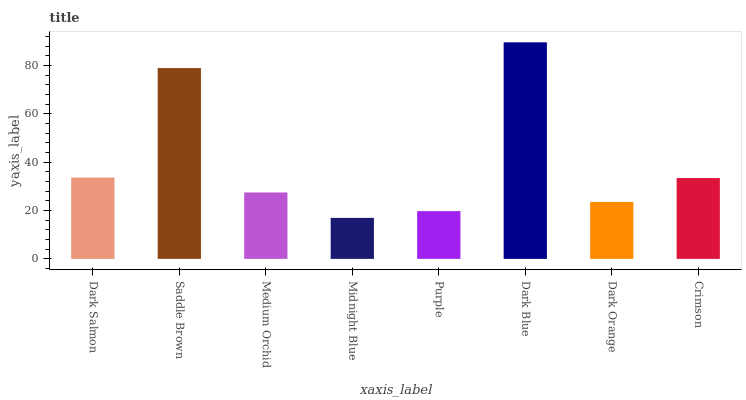Is Midnight Blue the minimum?
Answer yes or no. Yes. Is Dark Blue the maximum?
Answer yes or no. Yes. Is Saddle Brown the minimum?
Answer yes or no. No. Is Saddle Brown the maximum?
Answer yes or no. No. Is Saddle Brown greater than Dark Salmon?
Answer yes or no. Yes. Is Dark Salmon less than Saddle Brown?
Answer yes or no. Yes. Is Dark Salmon greater than Saddle Brown?
Answer yes or no. No. Is Saddle Brown less than Dark Salmon?
Answer yes or no. No. Is Crimson the high median?
Answer yes or no. Yes. Is Medium Orchid the low median?
Answer yes or no. Yes. Is Dark Salmon the high median?
Answer yes or no. No. Is Purple the low median?
Answer yes or no. No. 